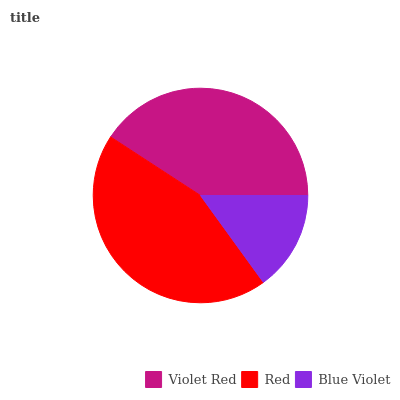Is Blue Violet the minimum?
Answer yes or no. Yes. Is Red the maximum?
Answer yes or no. Yes. Is Red the minimum?
Answer yes or no. No. Is Blue Violet the maximum?
Answer yes or no. No. Is Red greater than Blue Violet?
Answer yes or no. Yes. Is Blue Violet less than Red?
Answer yes or no. Yes. Is Blue Violet greater than Red?
Answer yes or no. No. Is Red less than Blue Violet?
Answer yes or no. No. Is Violet Red the high median?
Answer yes or no. Yes. Is Violet Red the low median?
Answer yes or no. Yes. Is Red the high median?
Answer yes or no. No. Is Blue Violet the low median?
Answer yes or no. No. 